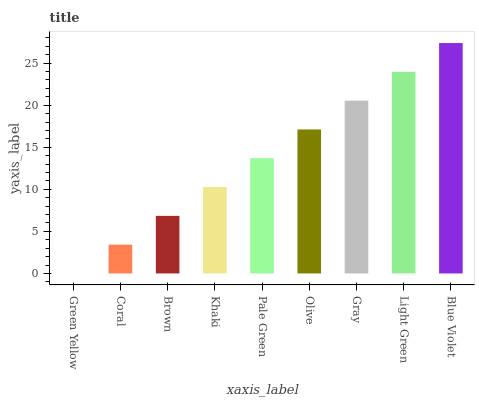Is Green Yellow the minimum?
Answer yes or no. Yes. Is Blue Violet the maximum?
Answer yes or no. Yes. Is Coral the minimum?
Answer yes or no. No. Is Coral the maximum?
Answer yes or no. No. Is Coral greater than Green Yellow?
Answer yes or no. Yes. Is Green Yellow less than Coral?
Answer yes or no. Yes. Is Green Yellow greater than Coral?
Answer yes or no. No. Is Coral less than Green Yellow?
Answer yes or no. No. Is Pale Green the high median?
Answer yes or no. Yes. Is Pale Green the low median?
Answer yes or no. Yes. Is Gray the high median?
Answer yes or no. No. Is Light Green the low median?
Answer yes or no. No. 